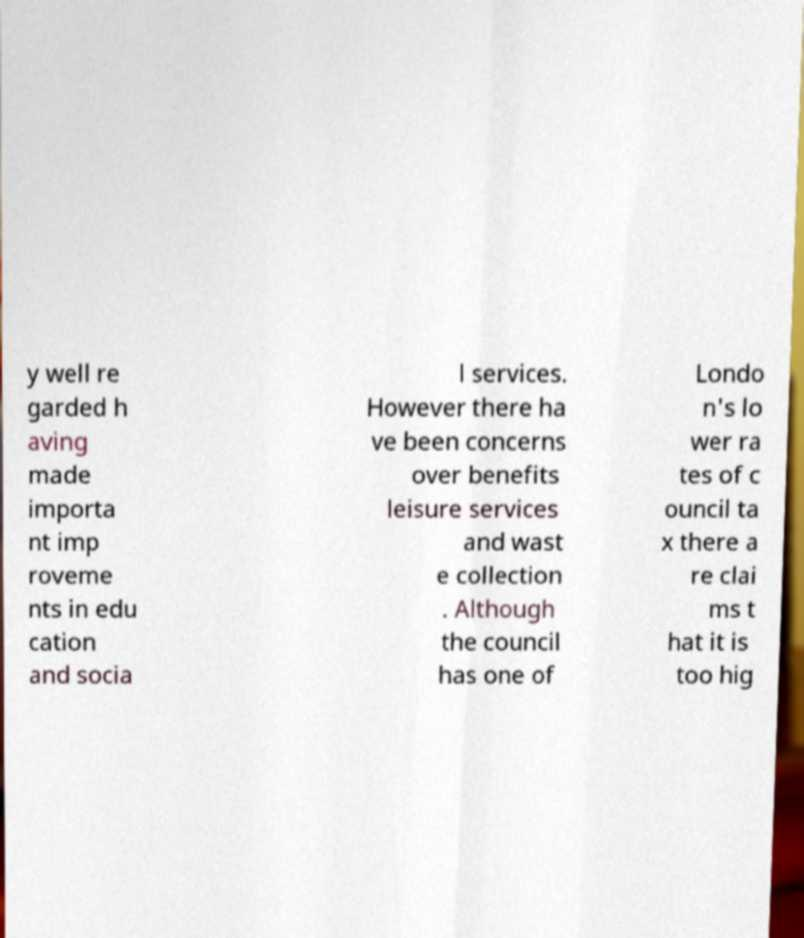What messages or text are displayed in this image? I need them in a readable, typed format. y well re garded h aving made importa nt imp roveme nts in edu cation and socia l services. However there ha ve been concerns over benefits leisure services and wast e collection . Although the council has one of Londo n's lo wer ra tes of c ouncil ta x there a re clai ms t hat it is too hig 